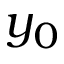<formula> <loc_0><loc_0><loc_500><loc_500>y _ { 0 }</formula> 